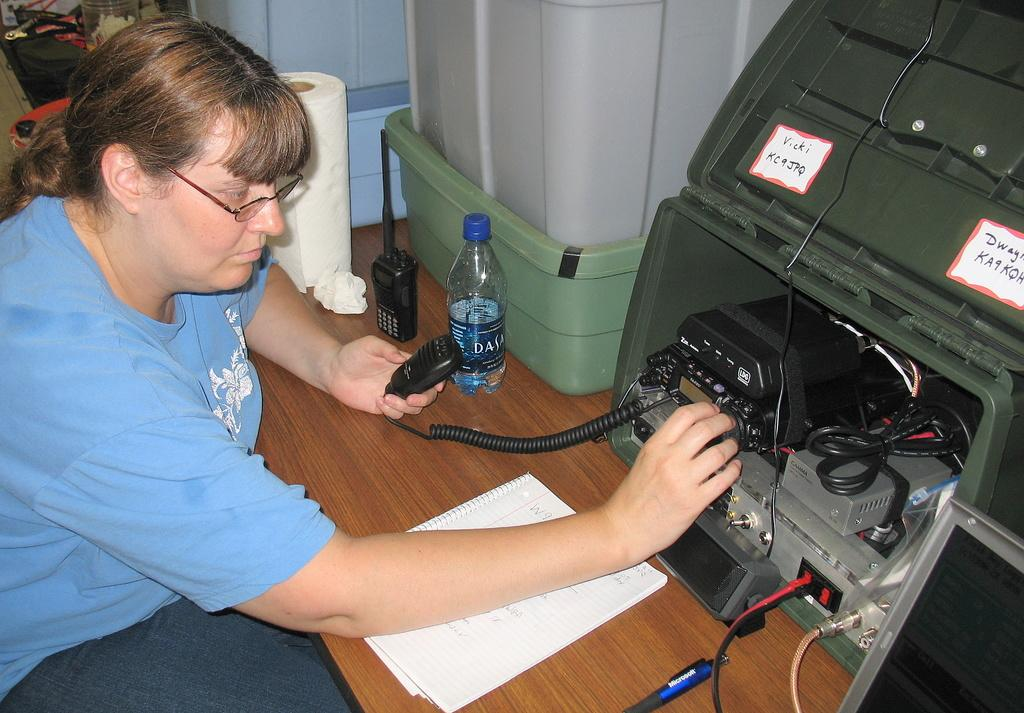<image>
Relay a brief, clear account of the picture shown. A woman working on a cb with the sign Vicki KC9JPQ stuck to it 